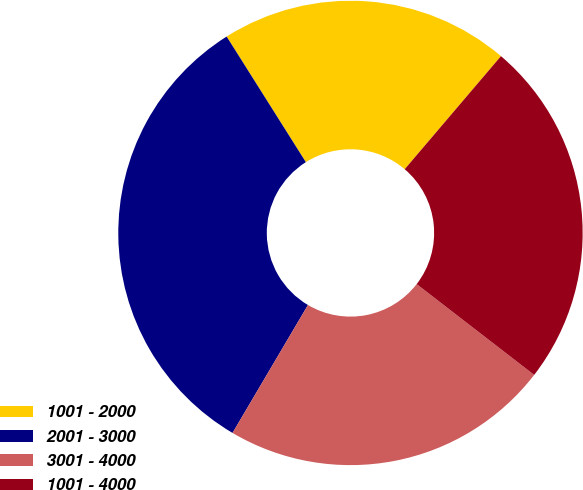Convert chart. <chart><loc_0><loc_0><loc_500><loc_500><pie_chart><fcel>1001 - 2000<fcel>2001 - 3000<fcel>3001 - 4000<fcel>1001 - 4000<nl><fcel>20.18%<fcel>32.57%<fcel>23.01%<fcel>24.25%<nl></chart> 